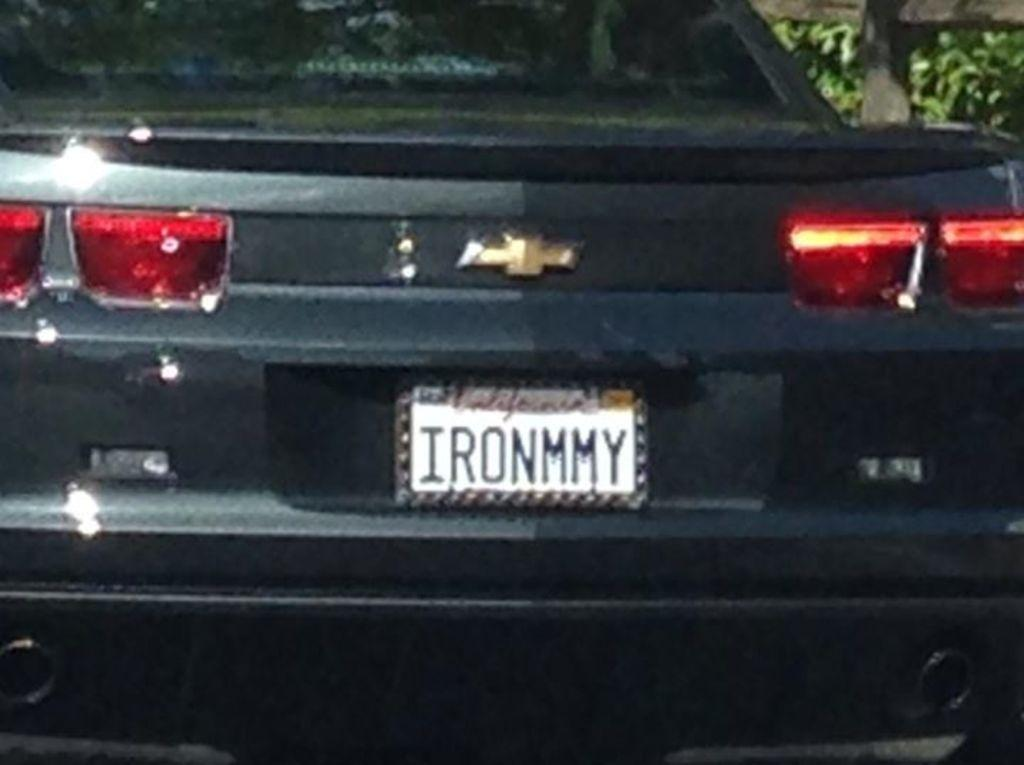What is the main subject of the image? There is a car in the center of the image. What color is the car? The car is black in color. Is there any text visible on the car? Yes, there is text written on the backside of the car. What can be seen on the right side of the image? There are plants on the right side of the image. How many eyes can be seen on the car in the image? There are no eyes visible on the car in the image, as cars do not have eyes. 